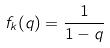Convert formula to latex. <formula><loc_0><loc_0><loc_500><loc_500>f _ { k } ( q ) = \frac { 1 } { 1 - q }</formula> 